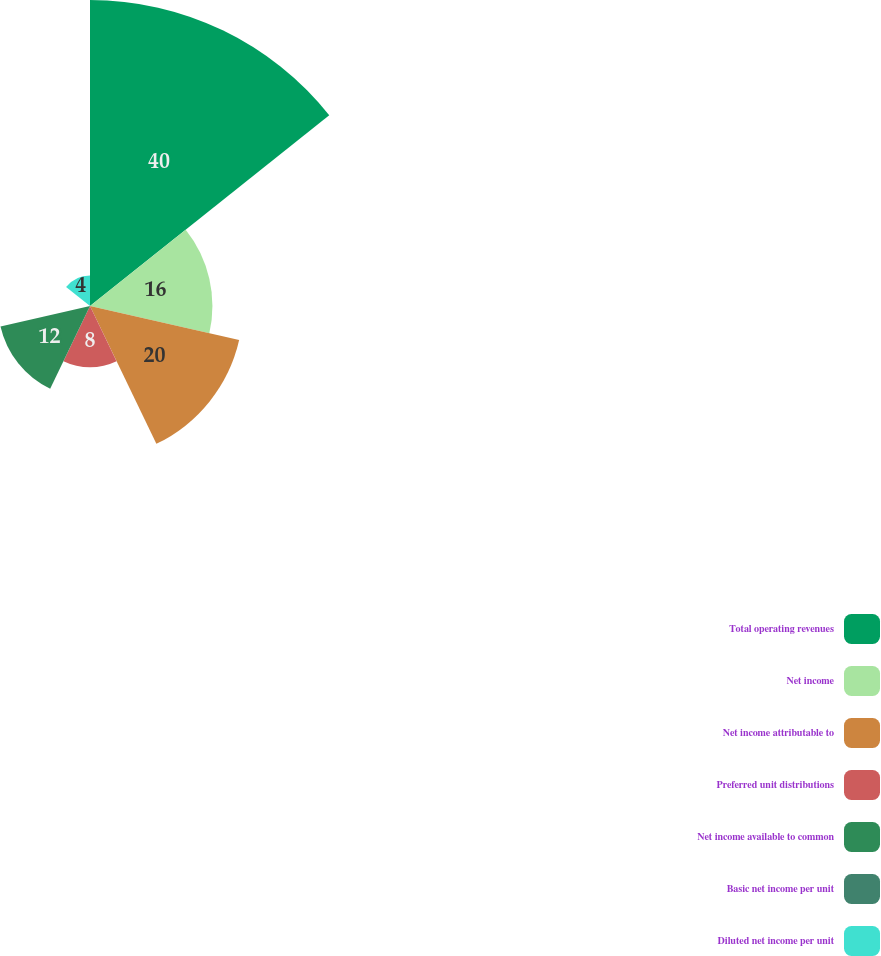Convert chart. <chart><loc_0><loc_0><loc_500><loc_500><pie_chart><fcel>Total operating revenues<fcel>Net income<fcel>Net income attributable to<fcel>Preferred unit distributions<fcel>Net income available to common<fcel>Basic net income per unit<fcel>Diluted net income per unit<nl><fcel>40.0%<fcel>16.0%<fcel>20.0%<fcel>8.0%<fcel>12.0%<fcel>0.0%<fcel>4.0%<nl></chart> 